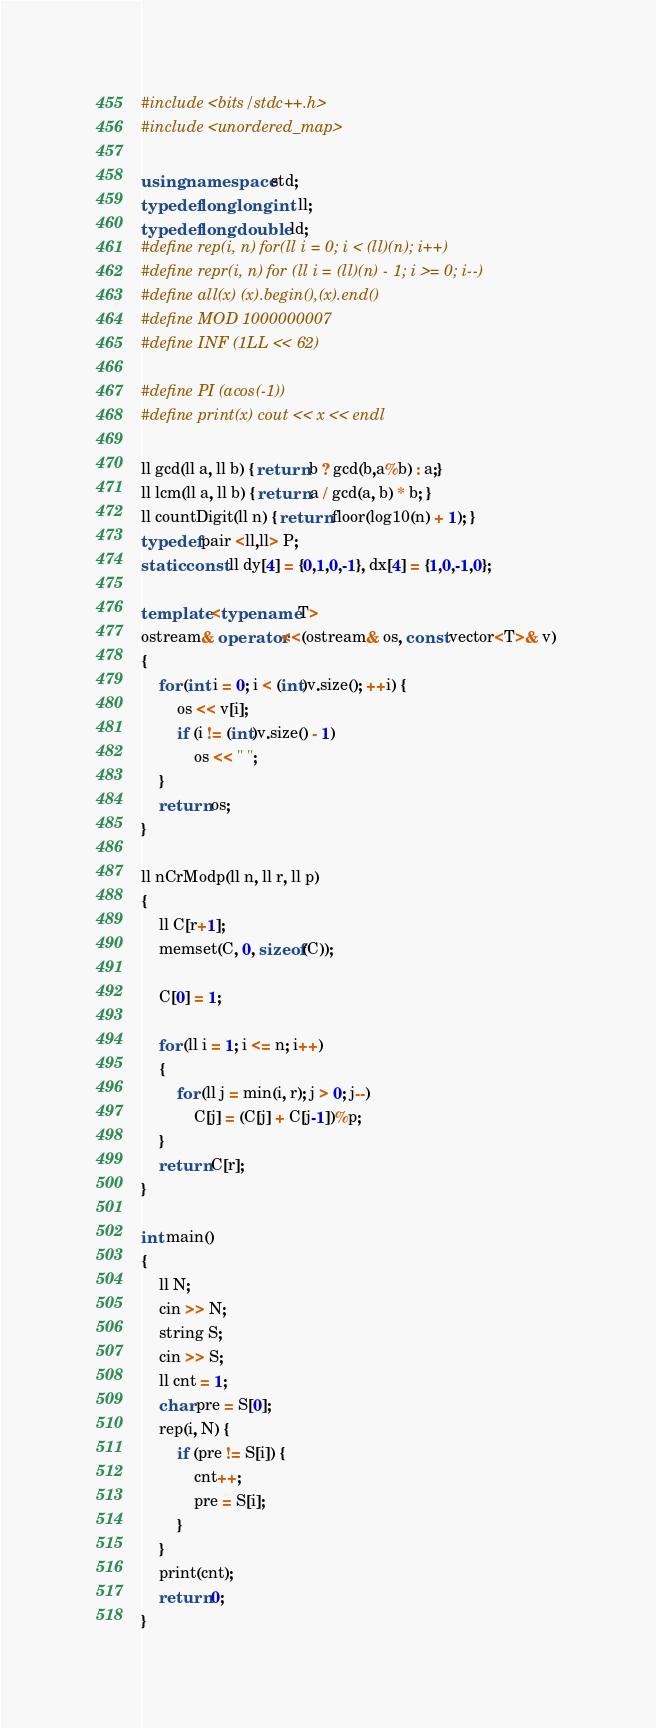Convert code to text. <code><loc_0><loc_0><loc_500><loc_500><_C++_>#include <bits/stdc++.h>
#include <unordered_map>

using namespace std;
typedef long long int ll;
typedef long double ld;
#define rep(i, n) for(ll i = 0; i < (ll)(n); i++)
#define repr(i, n) for (ll i = (ll)(n) - 1; i >= 0; i--)
#define all(x) (x).begin(),(x).end()
#define MOD 1000000007
#define INF (1LL << 62)

#define PI (acos(-1))
#define print(x) cout << x << endl
 
ll gcd(ll a, ll b) { return b ? gcd(b,a%b) : a;}
ll lcm(ll a, ll b) { return a / gcd(a, b) * b; }
ll countDigit(ll n) { return floor(log10(n) + 1); } 
typedef pair <ll,ll> P;
static const ll dy[4] = {0,1,0,-1}, dx[4] = {1,0,-1,0};

template <typename T> 
ostream& operator<<(ostream& os, const vector<T>& v) 
{ 
    for (int i = 0; i < (int)v.size(); ++i) { 
        os << v[i]; 
        if (i != (int)v.size() - 1) 
            os << " "; 
    } 
    return os; 
} 

ll nCrModp(ll n, ll r, ll p)
{
    ll C[r+1];
    memset(C, 0, sizeof(C));

    C[0] = 1;

    for (ll i = 1; i <= n; i++)
    {
        for (ll j = min(i, r); j > 0; j--)
            C[j] = (C[j] + C[j-1])%p;
    }
    return C[r];
}

int main()
{
    ll N;
    cin >> N;
    string S;
    cin >> S;
    ll cnt = 1;
    char pre = S[0];
    rep(i, N) {
        if (pre != S[i]) {
            cnt++;
            pre = S[i];
        }
    }
    print(cnt);
    return 0;
}</code> 